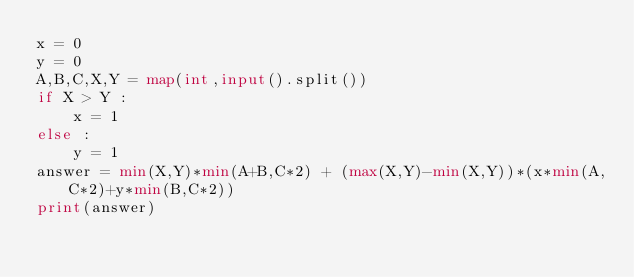Convert code to text. <code><loc_0><loc_0><loc_500><loc_500><_Python_>x = 0
y = 0
A,B,C,X,Y = map(int,input().split())
if X > Y :
    x = 1
else :
    y = 1
answer = min(X,Y)*min(A+B,C*2) + (max(X,Y)-min(X,Y))*(x*min(A,C*2)+y*min(B,C*2))
print(answer)

</code> 